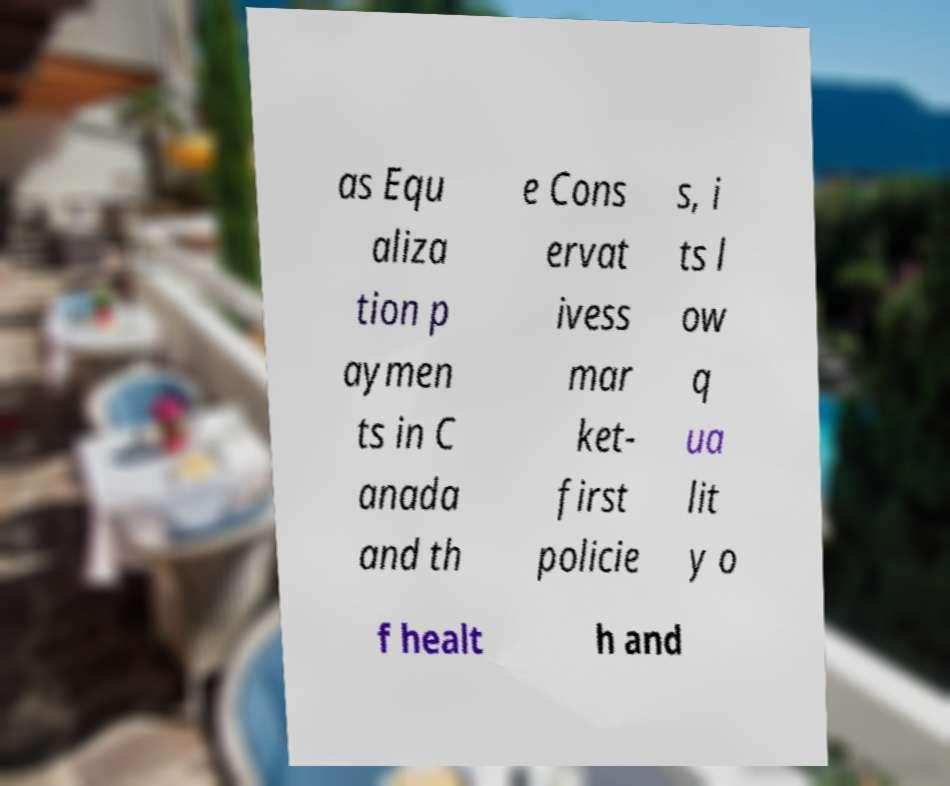Could you extract and type out the text from this image? as Equ aliza tion p aymen ts in C anada and th e Cons ervat ivess mar ket- first policie s, i ts l ow q ua lit y o f healt h and 